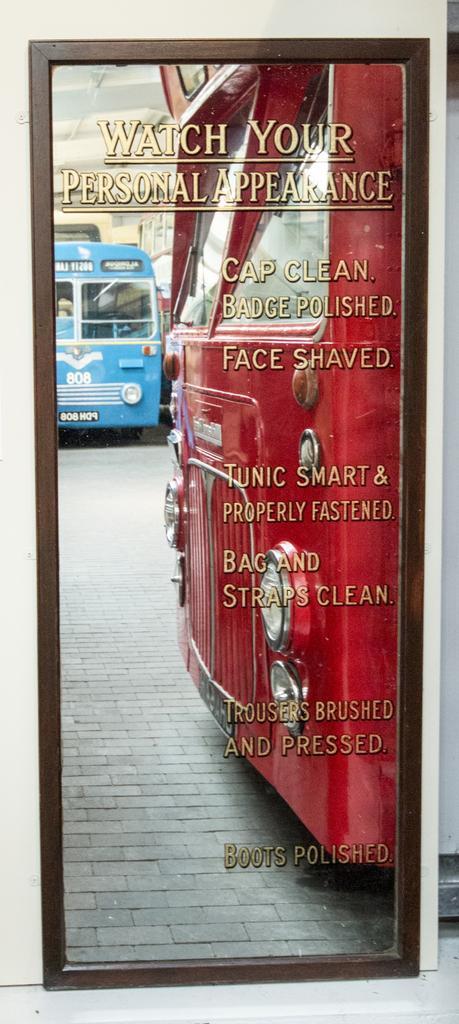Could you give a brief overview of what you see in this image? In this image we can see there is a mirror, on the mirror there are two buses parked and there is some text on it. 